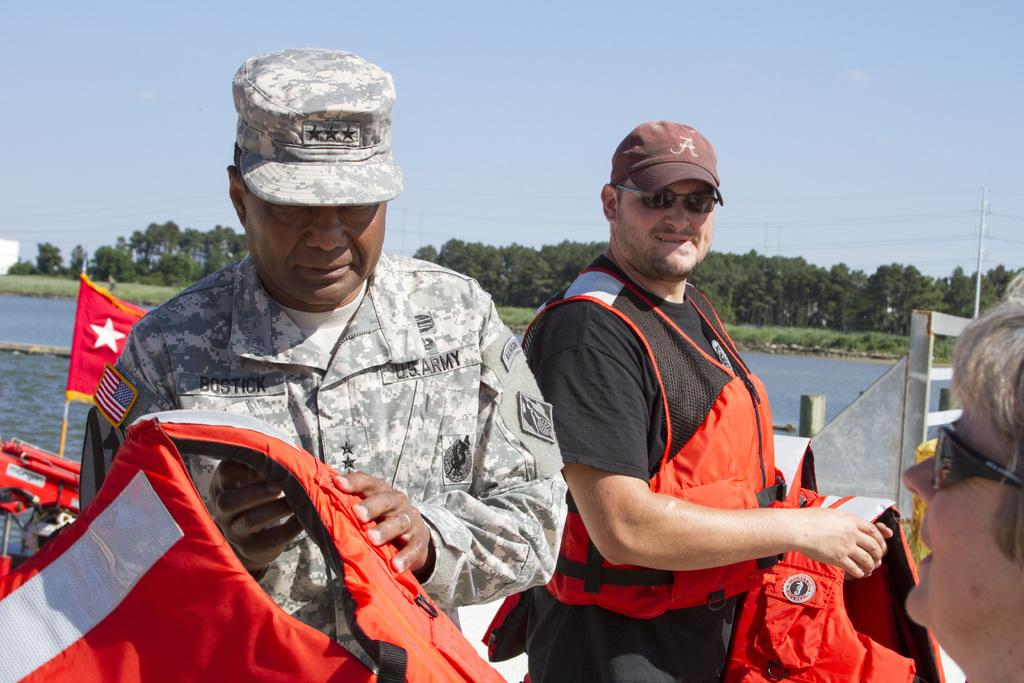How many people are in the image? There are three people in the image. What are two of the people holding? Two men are holding swimming jackets. What position are the men's hands in? The men have their hands behind them. What can be seen in the foreground of the image? There is a water surface visible in the image. What is visible in the background of the image? There are many trees in the background of the image. Can you describe the flight of the men in the image? There is no flight or air travel depicted in the image; it features three people standing near a water surface. How many men are turning around in the image? There is no indication that any of the men are turning around in the image. 